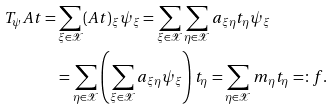<formula> <loc_0><loc_0><loc_500><loc_500>T _ { \psi } A t = & \sum _ { \xi \in \mathcal { X } } ( A t ) _ { \xi } \psi _ { \xi } = \sum _ { \xi \in \mathcal { X } } \sum _ { \eta \in \mathcal { X } } a _ { \xi \eta } t _ { \eta } \psi _ { \xi } \\ & = \sum _ { \eta \in \mathcal { X } } \left ( \sum _ { \xi \in \mathcal { X } } a _ { \xi \eta } \psi _ { \xi } \right ) t _ { \eta } = \sum _ { \eta \in \mathcal { X } } m _ { \eta } t _ { \eta } = \colon f .</formula> 